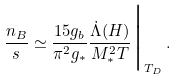Convert formula to latex. <formula><loc_0><loc_0><loc_500><loc_500>\frac { n _ { B } } { s } \simeq \frac { 1 5 g _ { b } } { \pi ^ { 2 } g _ { * } } \frac { \dot { \Lambda } ( H ) } { M _ { * } ^ { 2 } { T } } \Big { | } _ { T _ { D } } \, .</formula> 